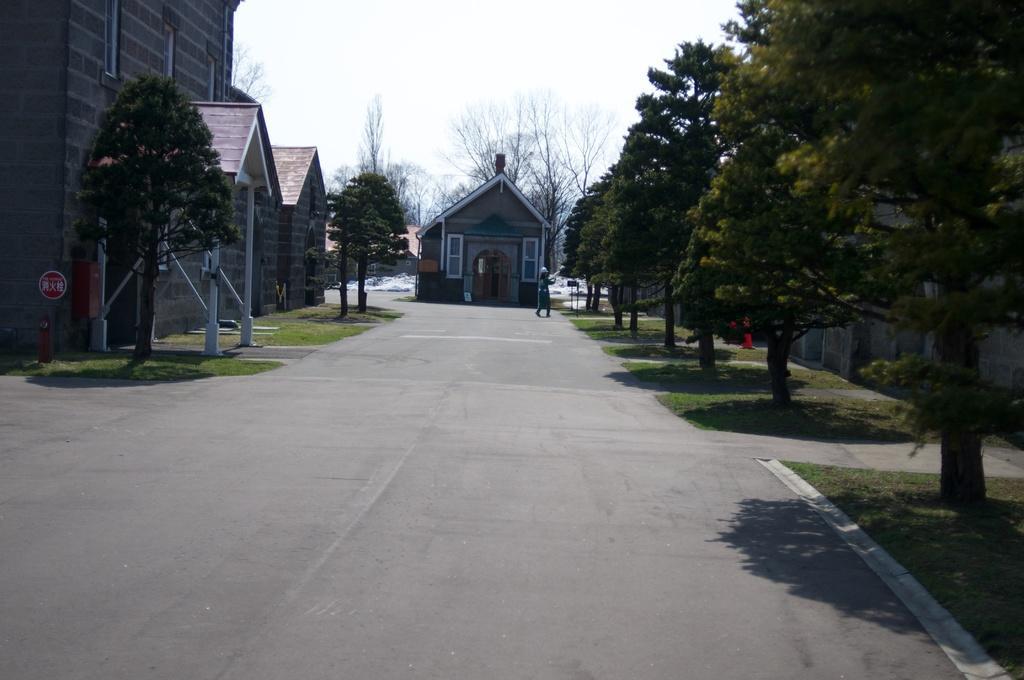Could you give a brief overview of what you see in this image? This image is taken on a road. On the left side there is a building and there are trees and there is a fire hydrant in front of the building. On the ground there is grass. In the center there is a home and there are dry trees and the person in front of the building is standing. On the right side there are trees and there's grass on the ground. 